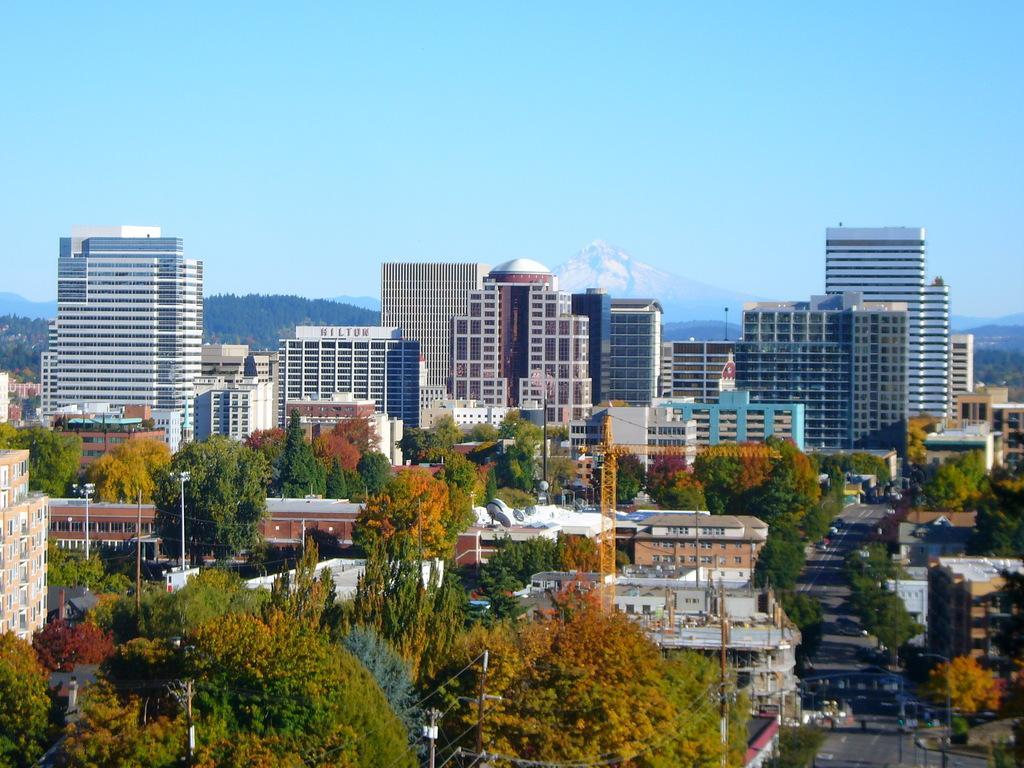How would you summarize this image in a sentence or two? In this image there are buildings, trees, some vehicles are on the road, utility poles, mountains and a sky. 